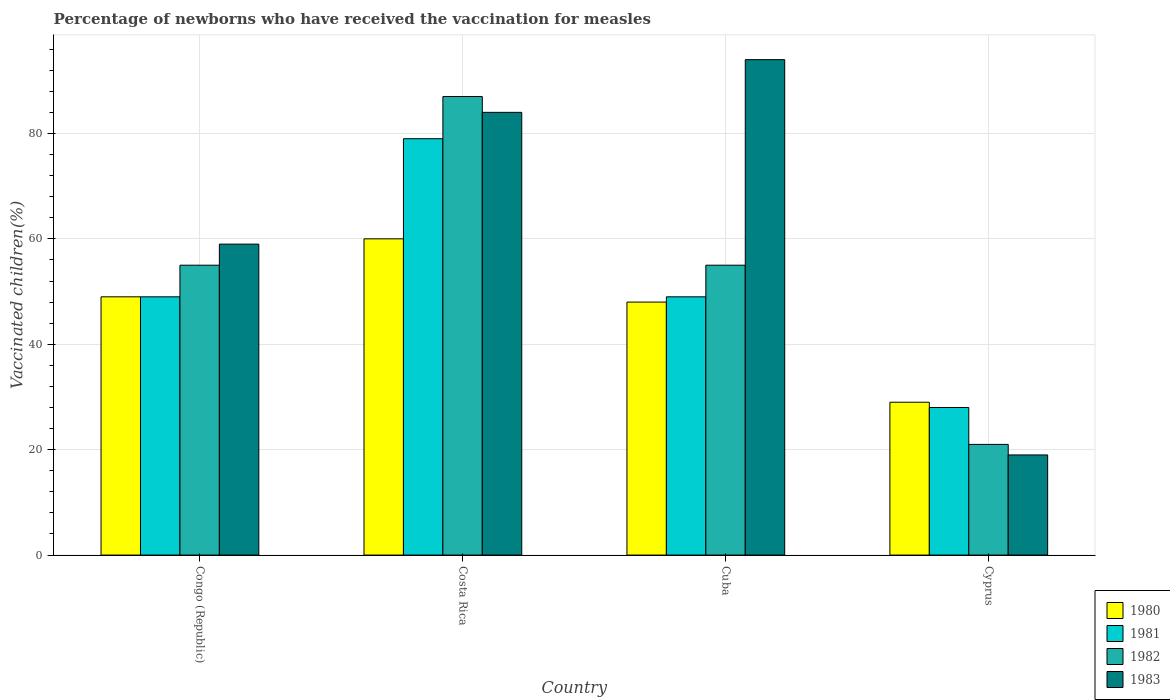How many groups of bars are there?
Offer a very short reply. 4. Are the number of bars on each tick of the X-axis equal?
Your response must be concise. Yes. How many bars are there on the 4th tick from the right?
Your response must be concise. 4. What is the percentage of vaccinated children in 1983 in Congo (Republic)?
Make the answer very short. 59. Across all countries, what is the maximum percentage of vaccinated children in 1982?
Provide a short and direct response. 87. Across all countries, what is the minimum percentage of vaccinated children in 1980?
Offer a very short reply. 29. In which country was the percentage of vaccinated children in 1980 maximum?
Your response must be concise. Costa Rica. In which country was the percentage of vaccinated children in 1980 minimum?
Give a very brief answer. Cyprus. What is the total percentage of vaccinated children in 1983 in the graph?
Give a very brief answer. 256. What is the difference between the percentage of vaccinated children in 1981 in Costa Rica and that in Cuba?
Offer a terse response. 30. What is the difference between the percentage of vaccinated children in 1980 in Cuba and the percentage of vaccinated children in 1983 in Cyprus?
Ensure brevity in your answer.  29. What is the average percentage of vaccinated children in 1982 per country?
Offer a terse response. 54.5. In how many countries, is the percentage of vaccinated children in 1982 greater than 64 %?
Offer a terse response. 1. What is the ratio of the percentage of vaccinated children in 1983 in Congo (Republic) to that in Costa Rica?
Your response must be concise. 0.7. Is the percentage of vaccinated children in 1980 in Congo (Republic) less than that in Costa Rica?
Keep it short and to the point. Yes. What is the difference between the highest and the second highest percentage of vaccinated children in 1983?
Make the answer very short. -25. What is the difference between the highest and the lowest percentage of vaccinated children in 1983?
Provide a succinct answer. 75. In how many countries, is the percentage of vaccinated children in 1980 greater than the average percentage of vaccinated children in 1980 taken over all countries?
Keep it short and to the point. 3. Is the sum of the percentage of vaccinated children in 1981 in Costa Rica and Cuba greater than the maximum percentage of vaccinated children in 1982 across all countries?
Ensure brevity in your answer.  Yes. What does the 4th bar from the left in Costa Rica represents?
Offer a terse response. 1983. How many bars are there?
Offer a very short reply. 16. Are all the bars in the graph horizontal?
Your answer should be compact. No. How many countries are there in the graph?
Make the answer very short. 4. Where does the legend appear in the graph?
Your answer should be compact. Bottom right. How many legend labels are there?
Give a very brief answer. 4. How are the legend labels stacked?
Give a very brief answer. Vertical. What is the title of the graph?
Your answer should be compact. Percentage of newborns who have received the vaccination for measles. What is the label or title of the Y-axis?
Keep it short and to the point. Vaccinated children(%). What is the Vaccinated children(%) in 1982 in Congo (Republic)?
Provide a succinct answer. 55. What is the Vaccinated children(%) of 1983 in Congo (Republic)?
Provide a succinct answer. 59. What is the Vaccinated children(%) in 1980 in Costa Rica?
Your answer should be compact. 60. What is the Vaccinated children(%) of 1981 in Costa Rica?
Keep it short and to the point. 79. What is the Vaccinated children(%) in 1981 in Cuba?
Your response must be concise. 49. What is the Vaccinated children(%) in 1982 in Cuba?
Provide a short and direct response. 55. What is the Vaccinated children(%) of 1983 in Cuba?
Your response must be concise. 94. What is the Vaccinated children(%) of 1980 in Cyprus?
Your response must be concise. 29. What is the Vaccinated children(%) of 1982 in Cyprus?
Make the answer very short. 21. What is the Vaccinated children(%) in 1983 in Cyprus?
Ensure brevity in your answer.  19. Across all countries, what is the maximum Vaccinated children(%) of 1980?
Your response must be concise. 60. Across all countries, what is the maximum Vaccinated children(%) of 1981?
Provide a succinct answer. 79. Across all countries, what is the maximum Vaccinated children(%) of 1982?
Provide a short and direct response. 87. Across all countries, what is the maximum Vaccinated children(%) in 1983?
Provide a succinct answer. 94. Across all countries, what is the minimum Vaccinated children(%) of 1980?
Ensure brevity in your answer.  29. Across all countries, what is the minimum Vaccinated children(%) in 1982?
Ensure brevity in your answer.  21. Across all countries, what is the minimum Vaccinated children(%) of 1983?
Provide a succinct answer. 19. What is the total Vaccinated children(%) in 1980 in the graph?
Provide a succinct answer. 186. What is the total Vaccinated children(%) of 1981 in the graph?
Offer a very short reply. 205. What is the total Vaccinated children(%) in 1982 in the graph?
Ensure brevity in your answer.  218. What is the total Vaccinated children(%) of 1983 in the graph?
Offer a very short reply. 256. What is the difference between the Vaccinated children(%) in 1981 in Congo (Republic) and that in Costa Rica?
Your response must be concise. -30. What is the difference between the Vaccinated children(%) of 1982 in Congo (Republic) and that in Costa Rica?
Make the answer very short. -32. What is the difference between the Vaccinated children(%) in 1983 in Congo (Republic) and that in Cuba?
Your answer should be compact. -35. What is the difference between the Vaccinated children(%) in 1981 in Congo (Republic) and that in Cyprus?
Provide a short and direct response. 21. What is the difference between the Vaccinated children(%) of 1982 in Costa Rica and that in Cuba?
Give a very brief answer. 32. What is the difference between the Vaccinated children(%) of 1983 in Costa Rica and that in Cuba?
Your answer should be compact. -10. What is the difference between the Vaccinated children(%) in 1980 in Costa Rica and that in Cyprus?
Ensure brevity in your answer.  31. What is the difference between the Vaccinated children(%) in 1982 in Costa Rica and that in Cyprus?
Offer a terse response. 66. What is the difference between the Vaccinated children(%) in 1983 in Costa Rica and that in Cyprus?
Your response must be concise. 65. What is the difference between the Vaccinated children(%) of 1980 in Congo (Republic) and the Vaccinated children(%) of 1982 in Costa Rica?
Provide a short and direct response. -38. What is the difference between the Vaccinated children(%) in 1980 in Congo (Republic) and the Vaccinated children(%) in 1983 in Costa Rica?
Provide a succinct answer. -35. What is the difference between the Vaccinated children(%) of 1981 in Congo (Republic) and the Vaccinated children(%) of 1982 in Costa Rica?
Your answer should be compact. -38. What is the difference between the Vaccinated children(%) in 1981 in Congo (Republic) and the Vaccinated children(%) in 1983 in Costa Rica?
Offer a very short reply. -35. What is the difference between the Vaccinated children(%) of 1982 in Congo (Republic) and the Vaccinated children(%) of 1983 in Costa Rica?
Provide a short and direct response. -29. What is the difference between the Vaccinated children(%) in 1980 in Congo (Republic) and the Vaccinated children(%) in 1983 in Cuba?
Offer a terse response. -45. What is the difference between the Vaccinated children(%) of 1981 in Congo (Republic) and the Vaccinated children(%) of 1983 in Cuba?
Your answer should be compact. -45. What is the difference between the Vaccinated children(%) in 1982 in Congo (Republic) and the Vaccinated children(%) in 1983 in Cuba?
Provide a short and direct response. -39. What is the difference between the Vaccinated children(%) of 1980 in Costa Rica and the Vaccinated children(%) of 1983 in Cuba?
Ensure brevity in your answer.  -34. What is the difference between the Vaccinated children(%) in 1981 in Costa Rica and the Vaccinated children(%) in 1982 in Cuba?
Ensure brevity in your answer.  24. What is the difference between the Vaccinated children(%) in 1980 in Costa Rica and the Vaccinated children(%) in 1982 in Cyprus?
Give a very brief answer. 39. What is the difference between the Vaccinated children(%) of 1980 in Costa Rica and the Vaccinated children(%) of 1983 in Cyprus?
Your response must be concise. 41. What is the difference between the Vaccinated children(%) of 1981 in Costa Rica and the Vaccinated children(%) of 1982 in Cyprus?
Offer a terse response. 58. What is the difference between the Vaccinated children(%) in 1981 in Costa Rica and the Vaccinated children(%) in 1983 in Cyprus?
Your response must be concise. 60. What is the difference between the Vaccinated children(%) in 1980 in Cuba and the Vaccinated children(%) in 1981 in Cyprus?
Your response must be concise. 20. What is the difference between the Vaccinated children(%) in 1980 in Cuba and the Vaccinated children(%) in 1982 in Cyprus?
Provide a short and direct response. 27. What is the difference between the Vaccinated children(%) in 1981 in Cuba and the Vaccinated children(%) in 1982 in Cyprus?
Your answer should be compact. 28. What is the average Vaccinated children(%) in 1980 per country?
Give a very brief answer. 46.5. What is the average Vaccinated children(%) in 1981 per country?
Make the answer very short. 51.25. What is the average Vaccinated children(%) in 1982 per country?
Provide a short and direct response. 54.5. What is the average Vaccinated children(%) of 1983 per country?
Give a very brief answer. 64. What is the difference between the Vaccinated children(%) in 1980 and Vaccinated children(%) in 1981 in Congo (Republic)?
Provide a succinct answer. 0. What is the difference between the Vaccinated children(%) of 1980 and Vaccinated children(%) of 1982 in Congo (Republic)?
Your answer should be very brief. -6. What is the difference between the Vaccinated children(%) of 1980 and Vaccinated children(%) of 1983 in Congo (Republic)?
Your response must be concise. -10. What is the difference between the Vaccinated children(%) in 1980 and Vaccinated children(%) in 1981 in Costa Rica?
Offer a terse response. -19. What is the difference between the Vaccinated children(%) of 1981 and Vaccinated children(%) of 1983 in Costa Rica?
Make the answer very short. -5. What is the difference between the Vaccinated children(%) in 1980 and Vaccinated children(%) in 1981 in Cuba?
Offer a very short reply. -1. What is the difference between the Vaccinated children(%) in 1980 and Vaccinated children(%) in 1983 in Cuba?
Make the answer very short. -46. What is the difference between the Vaccinated children(%) of 1981 and Vaccinated children(%) of 1982 in Cuba?
Give a very brief answer. -6. What is the difference between the Vaccinated children(%) of 1981 and Vaccinated children(%) of 1983 in Cuba?
Offer a very short reply. -45. What is the difference between the Vaccinated children(%) in 1982 and Vaccinated children(%) in 1983 in Cuba?
Your answer should be compact. -39. What is the difference between the Vaccinated children(%) in 1980 and Vaccinated children(%) in 1983 in Cyprus?
Give a very brief answer. 10. What is the difference between the Vaccinated children(%) in 1981 and Vaccinated children(%) in 1982 in Cyprus?
Make the answer very short. 7. What is the ratio of the Vaccinated children(%) of 1980 in Congo (Republic) to that in Costa Rica?
Offer a terse response. 0.82. What is the ratio of the Vaccinated children(%) of 1981 in Congo (Republic) to that in Costa Rica?
Offer a terse response. 0.62. What is the ratio of the Vaccinated children(%) of 1982 in Congo (Republic) to that in Costa Rica?
Ensure brevity in your answer.  0.63. What is the ratio of the Vaccinated children(%) of 1983 in Congo (Republic) to that in Costa Rica?
Your answer should be very brief. 0.7. What is the ratio of the Vaccinated children(%) of 1980 in Congo (Republic) to that in Cuba?
Your response must be concise. 1.02. What is the ratio of the Vaccinated children(%) in 1982 in Congo (Republic) to that in Cuba?
Ensure brevity in your answer.  1. What is the ratio of the Vaccinated children(%) in 1983 in Congo (Republic) to that in Cuba?
Your response must be concise. 0.63. What is the ratio of the Vaccinated children(%) in 1980 in Congo (Republic) to that in Cyprus?
Your response must be concise. 1.69. What is the ratio of the Vaccinated children(%) of 1981 in Congo (Republic) to that in Cyprus?
Provide a succinct answer. 1.75. What is the ratio of the Vaccinated children(%) of 1982 in Congo (Republic) to that in Cyprus?
Your answer should be compact. 2.62. What is the ratio of the Vaccinated children(%) in 1983 in Congo (Republic) to that in Cyprus?
Give a very brief answer. 3.11. What is the ratio of the Vaccinated children(%) in 1980 in Costa Rica to that in Cuba?
Ensure brevity in your answer.  1.25. What is the ratio of the Vaccinated children(%) in 1981 in Costa Rica to that in Cuba?
Offer a very short reply. 1.61. What is the ratio of the Vaccinated children(%) of 1982 in Costa Rica to that in Cuba?
Provide a short and direct response. 1.58. What is the ratio of the Vaccinated children(%) of 1983 in Costa Rica to that in Cuba?
Offer a very short reply. 0.89. What is the ratio of the Vaccinated children(%) of 1980 in Costa Rica to that in Cyprus?
Provide a succinct answer. 2.07. What is the ratio of the Vaccinated children(%) of 1981 in Costa Rica to that in Cyprus?
Your response must be concise. 2.82. What is the ratio of the Vaccinated children(%) of 1982 in Costa Rica to that in Cyprus?
Your answer should be compact. 4.14. What is the ratio of the Vaccinated children(%) in 1983 in Costa Rica to that in Cyprus?
Offer a very short reply. 4.42. What is the ratio of the Vaccinated children(%) in 1980 in Cuba to that in Cyprus?
Offer a very short reply. 1.66. What is the ratio of the Vaccinated children(%) in 1982 in Cuba to that in Cyprus?
Give a very brief answer. 2.62. What is the ratio of the Vaccinated children(%) in 1983 in Cuba to that in Cyprus?
Your answer should be very brief. 4.95. What is the difference between the highest and the second highest Vaccinated children(%) in 1980?
Provide a succinct answer. 11. What is the difference between the highest and the second highest Vaccinated children(%) in 1982?
Offer a terse response. 32. What is the difference between the highest and the lowest Vaccinated children(%) of 1980?
Ensure brevity in your answer.  31. 